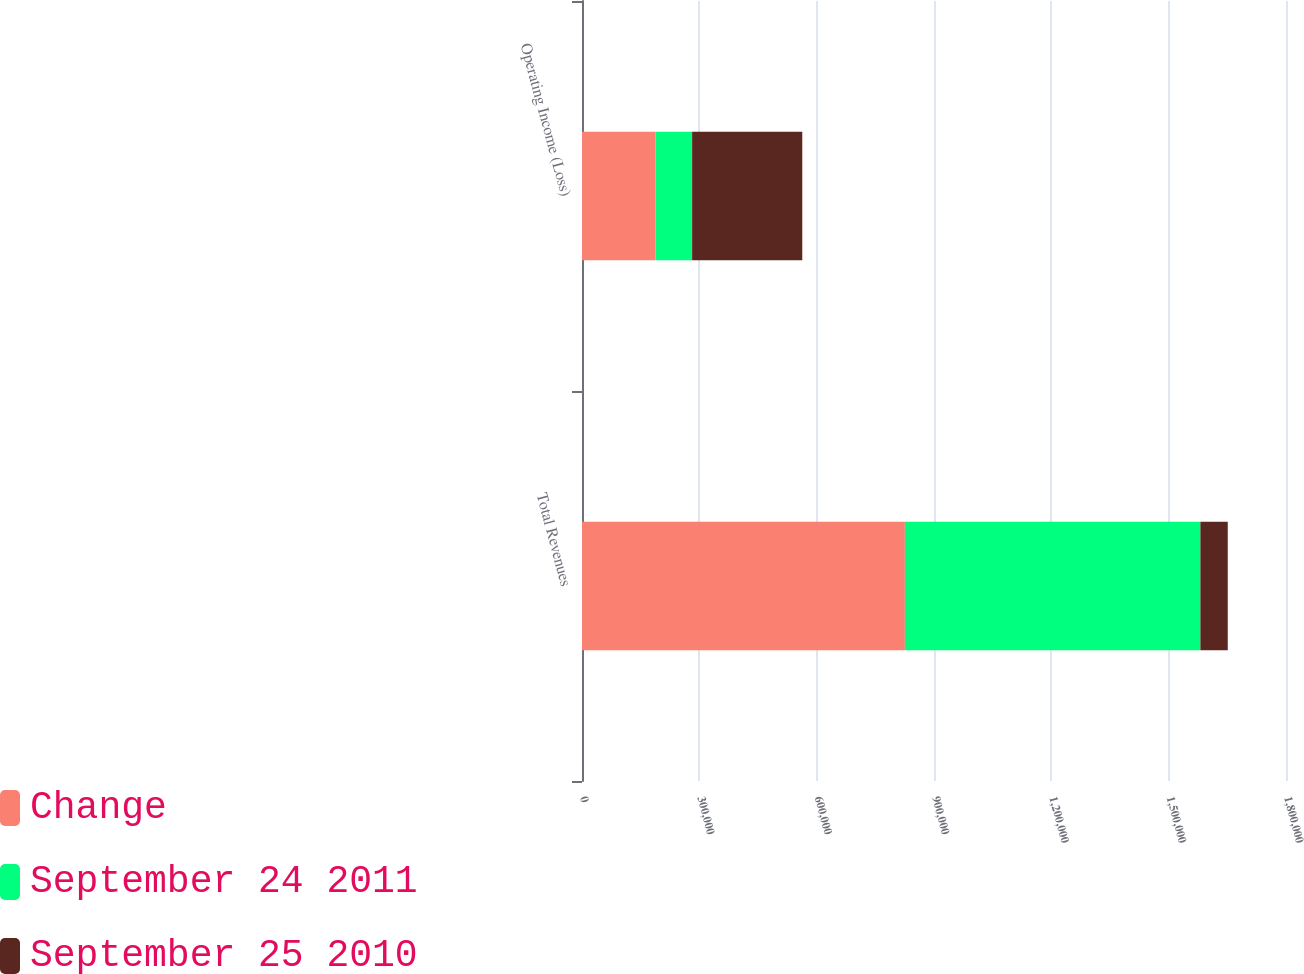<chart> <loc_0><loc_0><loc_500><loc_500><stacked_bar_chart><ecel><fcel>Total Revenues<fcel>Operating Income (Loss)<nl><fcel>Change<fcel>825551<fcel>187970<nl><fcel>September 24 2011<fcel>755542<fcel>93623<nl><fcel>September 25 2010<fcel>70009<fcel>281593<nl></chart> 